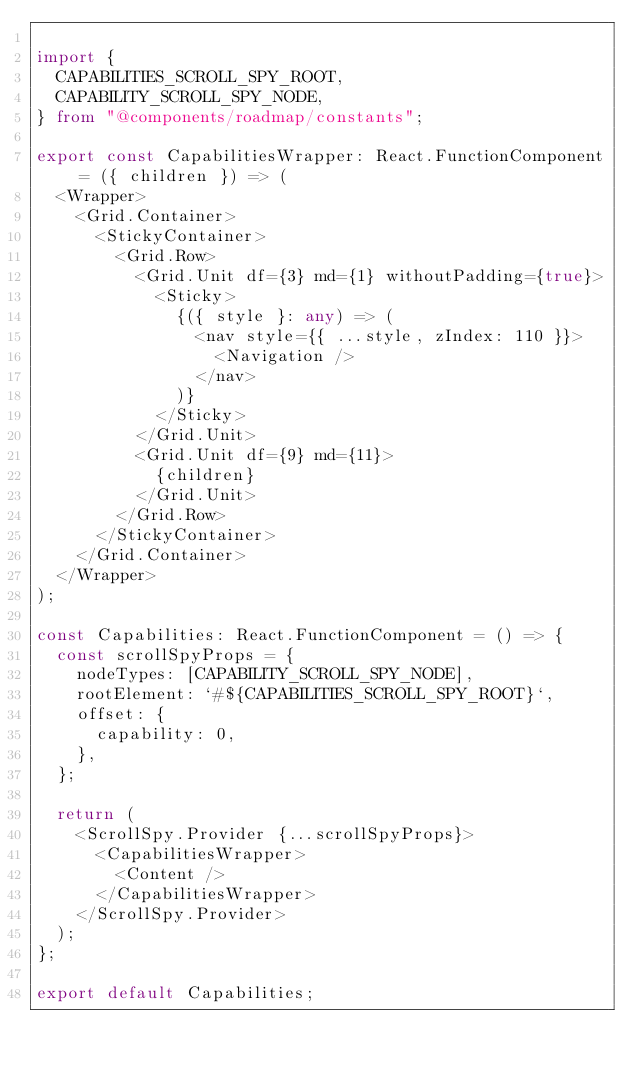Convert code to text. <code><loc_0><loc_0><loc_500><loc_500><_TypeScript_>
import {
  CAPABILITIES_SCROLL_SPY_ROOT,
  CAPABILITY_SCROLL_SPY_NODE,
} from "@components/roadmap/constants";

export const CapabilitiesWrapper: React.FunctionComponent = ({ children }) => (
  <Wrapper>
    <Grid.Container>
      <StickyContainer>
        <Grid.Row>
          <Grid.Unit df={3} md={1} withoutPadding={true}>
            <Sticky>
              {({ style }: any) => (
                <nav style={{ ...style, zIndex: 110 }}>
                  <Navigation />
                </nav>
              )}
            </Sticky>
          </Grid.Unit>
          <Grid.Unit df={9} md={11}>
            {children}
          </Grid.Unit>
        </Grid.Row>
      </StickyContainer>
    </Grid.Container>
  </Wrapper>
);

const Capabilities: React.FunctionComponent = () => {
  const scrollSpyProps = {
    nodeTypes: [CAPABILITY_SCROLL_SPY_NODE],
    rootElement: `#${CAPABILITIES_SCROLL_SPY_ROOT}`,
    offset: {
      capability: 0,
    },
  };

  return (
    <ScrollSpy.Provider {...scrollSpyProps}>
      <CapabilitiesWrapper>
        <Content />
      </CapabilitiesWrapper>
    </ScrollSpy.Provider>
  );
};

export default Capabilities;
</code> 